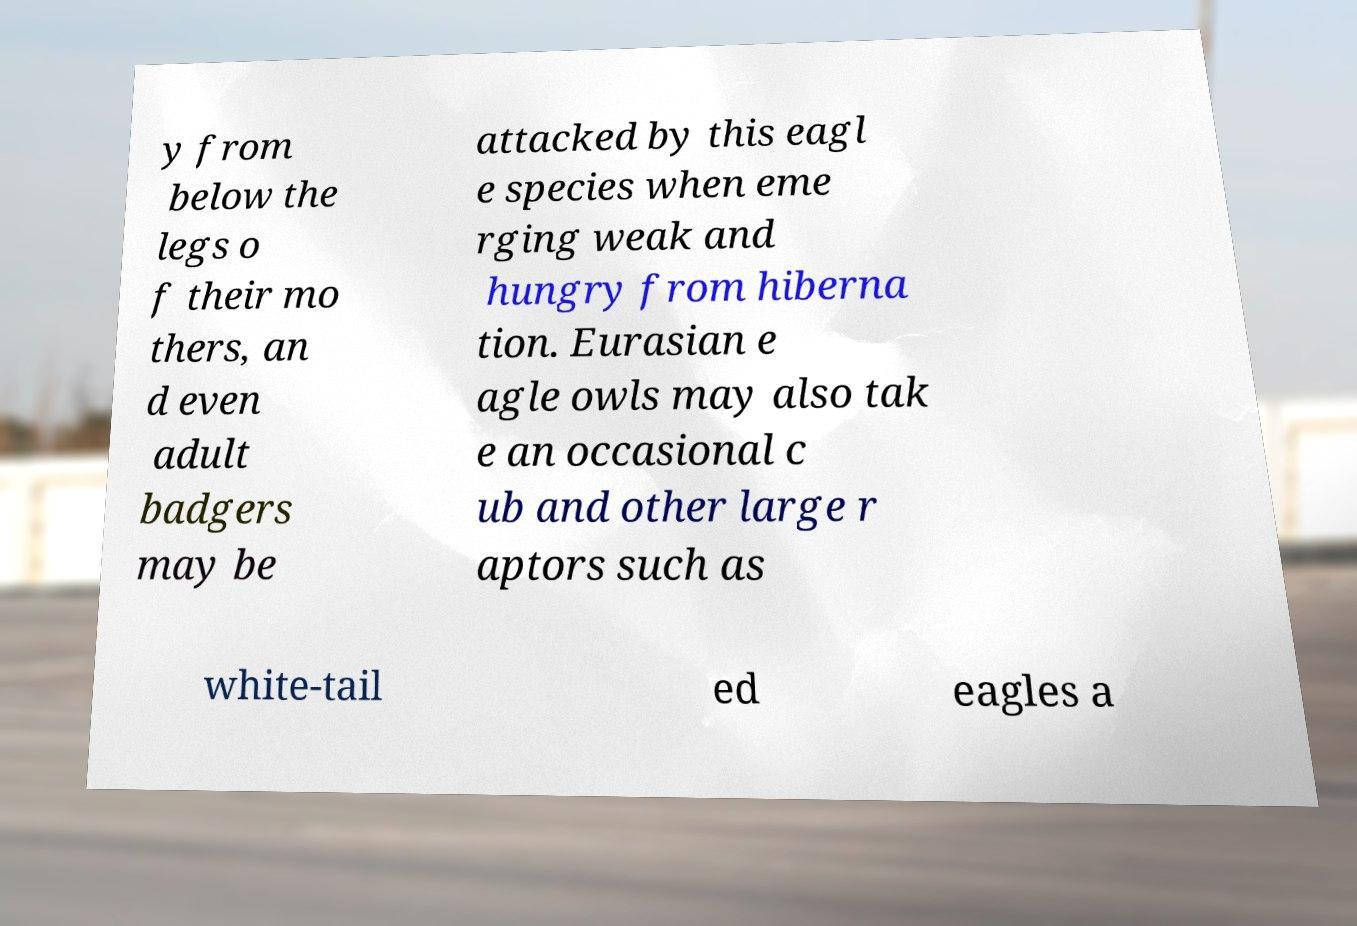There's text embedded in this image that I need extracted. Can you transcribe it verbatim? y from below the legs o f their mo thers, an d even adult badgers may be attacked by this eagl e species when eme rging weak and hungry from hiberna tion. Eurasian e agle owls may also tak e an occasional c ub and other large r aptors such as white-tail ed eagles a 